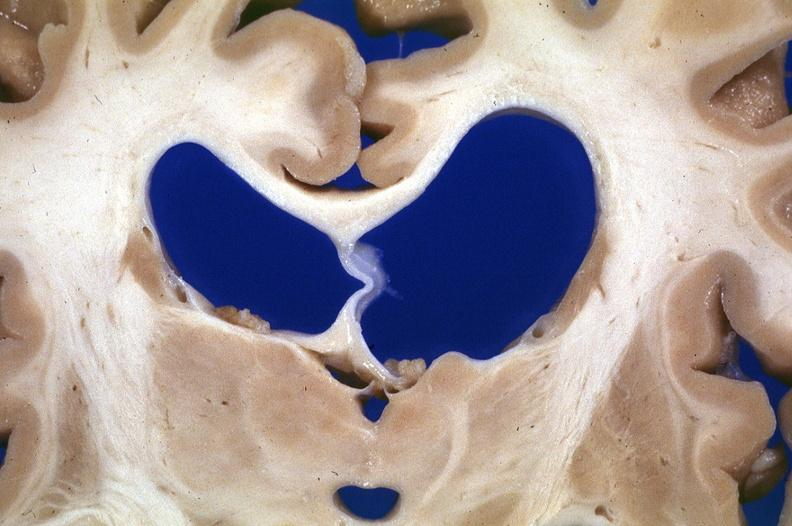what does this image show?
Answer the question using a single word or phrase. Brain 